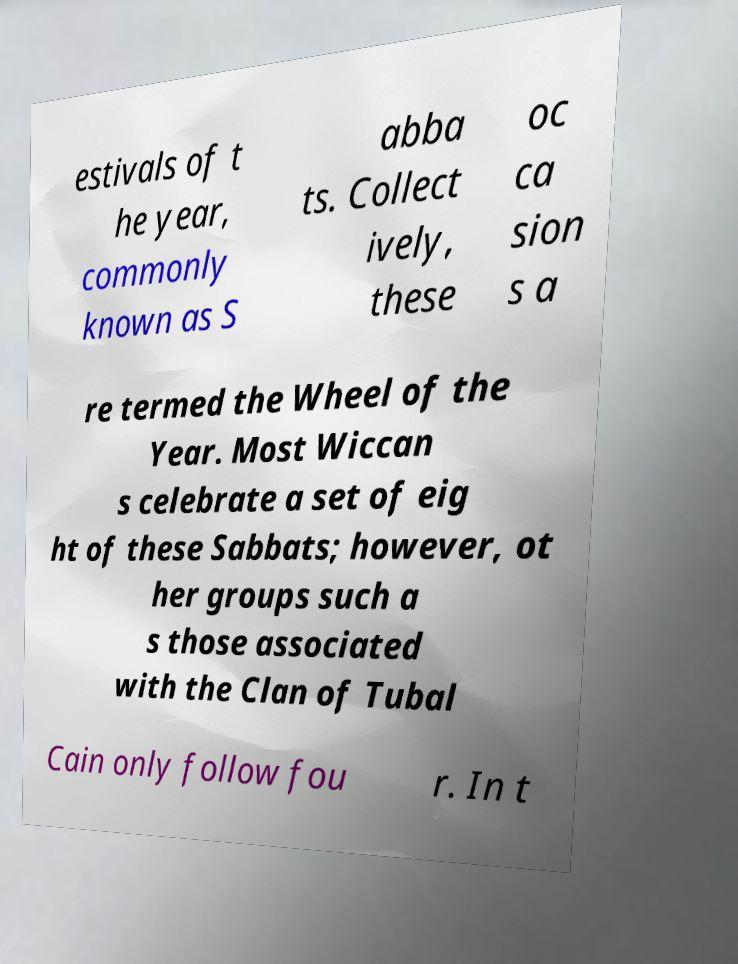Can you read and provide the text displayed in the image?This photo seems to have some interesting text. Can you extract and type it out for me? estivals of t he year, commonly known as S abba ts. Collect ively, these oc ca sion s a re termed the Wheel of the Year. Most Wiccan s celebrate a set of eig ht of these Sabbats; however, ot her groups such a s those associated with the Clan of Tubal Cain only follow fou r. In t 